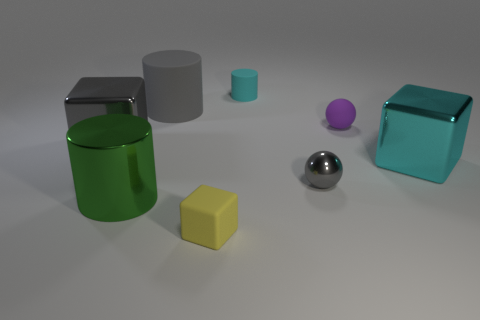Subtract all gray matte cylinders. How many cylinders are left? 2 Subtract 1 cylinders. How many cylinders are left? 2 Add 2 cyan cubes. How many objects exist? 10 Subtract all green cylinders. Subtract all red spheres. How many cylinders are left? 2 Subtract 1 gray cubes. How many objects are left? 7 Subtract all cylinders. How many objects are left? 5 Subtract all big cyan metal cubes. Subtract all tiny purple objects. How many objects are left? 6 Add 8 large cyan metal cubes. How many large cyan metal cubes are left? 9 Add 7 small shiny balls. How many small shiny balls exist? 8 